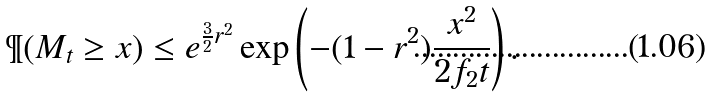<formula> <loc_0><loc_0><loc_500><loc_500>\P ( M _ { t } \geq x ) \leq e ^ { \frac { 3 } { 2 } r ^ { 2 } } \exp \left ( - ( 1 - r ^ { 2 } ) \frac { x ^ { 2 } } { 2 f _ { 2 } t } \right ) .</formula> 